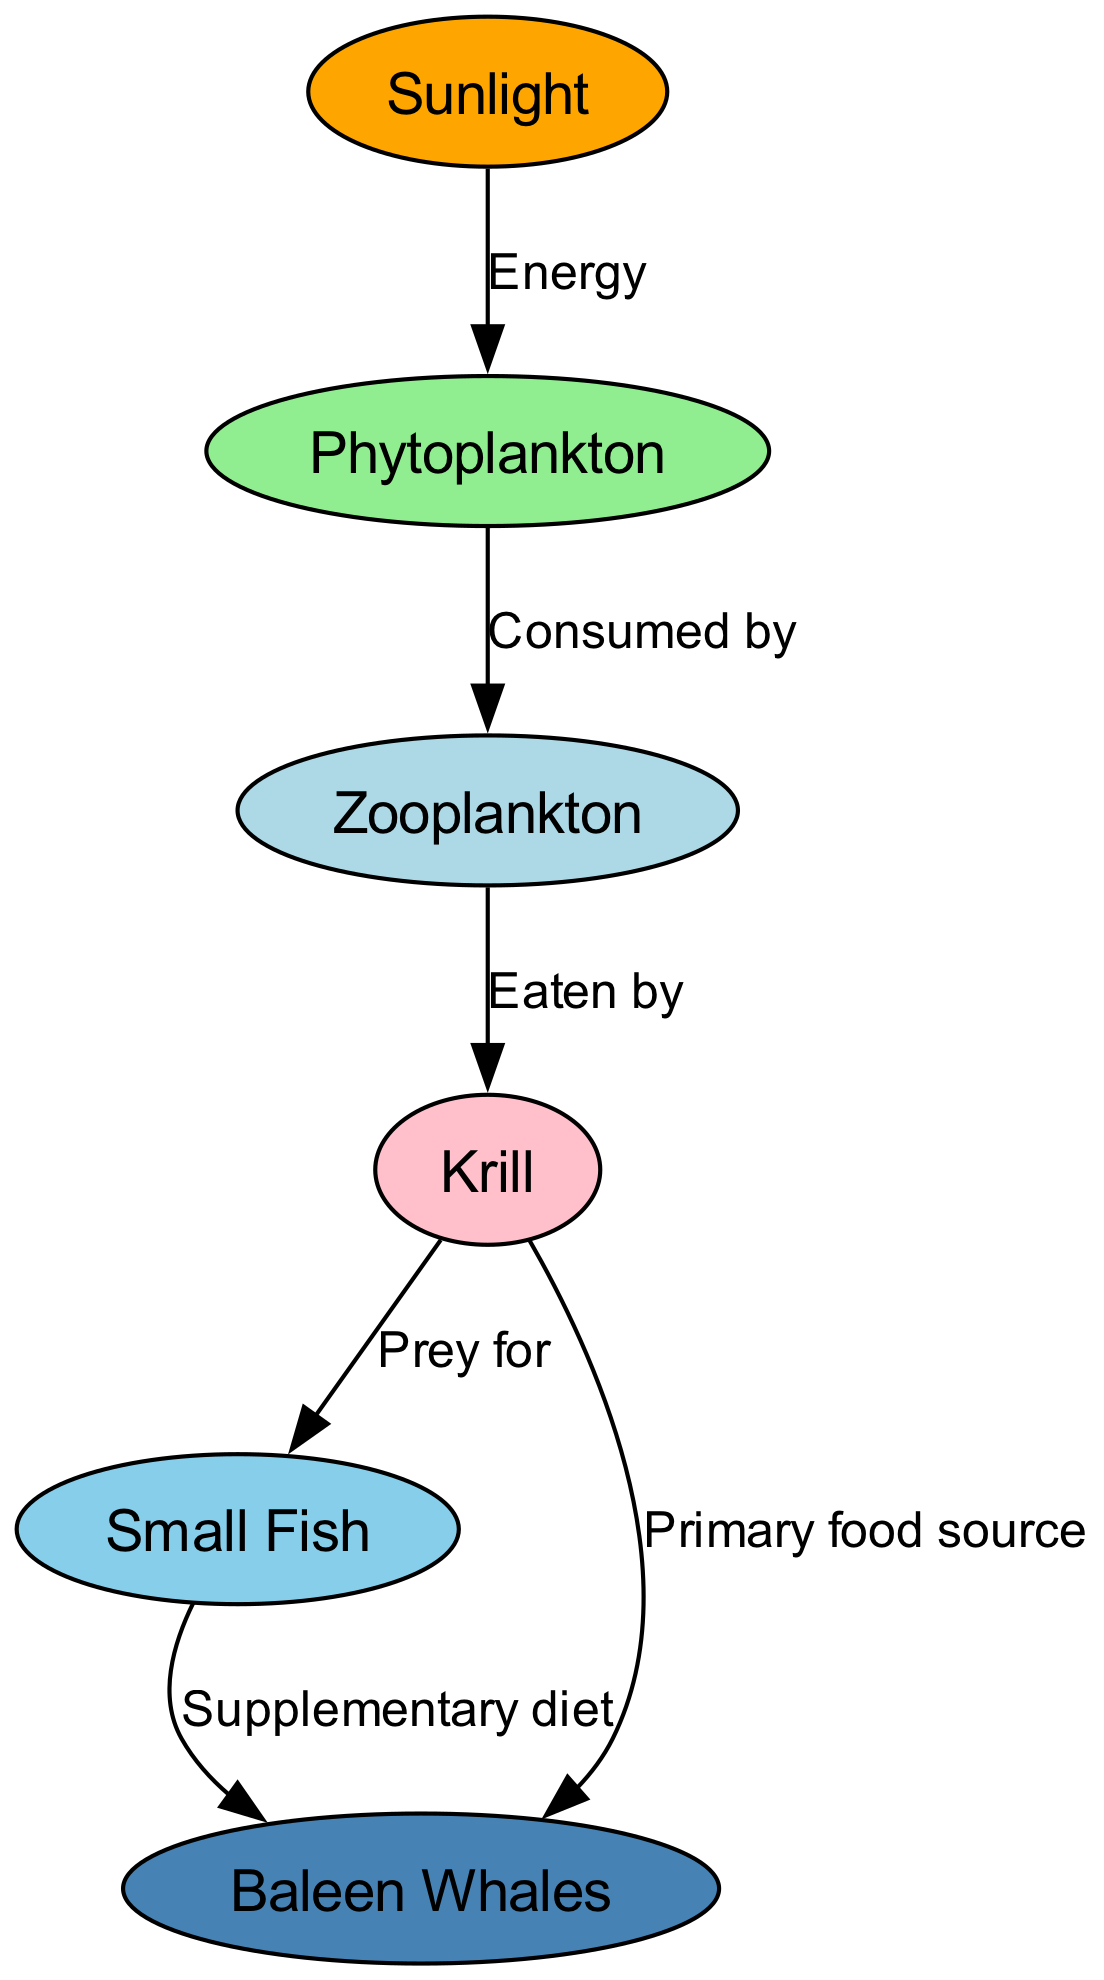What is the primary food source for baleen whales? The diagram indicates that krill is the primary food source for baleen whales, which is indicated by the direct edge labeled "Primary food source" connecting krill to baleen whales.
Answer: Krill How many nodes are in the diagram? Counting all the unique nodes depicted in the diagram, there are six nodes: Sunlight, Phytoplankton, Zooplankton, Krill, Small Fish, and Baleen Whales.
Answer: 6 What relationship does sunlight have with phytoplankton? The diagram shows that sunlight provides energy to phytoplankton, which is labeled by the edge connecting the two, with the label "Energy" indicating that sunlight is essential for phytoplankton's growth.
Answer: Energy Which organism is eaten by zooplankton? According to the diagram, zooplankton consumes phytoplankton; this direct relationship is indicated by the edge labeled "Consumed by" from phytoplankton to zooplankton.
Answer: Phytoplankton What type of fish supplements the diet of baleen whales? The diagram clearly shows that small fish serve as a supplementary diet for baleen whales, indicated by the edge connecting small fish to baleen whales with the label "Supplementary diet."
Answer: Small Fish Which two organisms are both prey for krill? The diagram illustrates that both small fish and baleen whales are described in connection to krill; however, only small fish is prey for krill while baleen whales rely significantly on krill as their primary food source, but baleen whales are not prey for krill. Thus, this can be interpreted such that the edge leading from krill to small fish indicates the prey relationship.
Answer: Small Fish Which organism is at the top of the food chain in this diagram? In the food chain illustrated here, baleen whales are positioned at the top, as they consume both krill and small fish, making them the apex predators in this chain.
Answer: Baleen Whales What role does krill play in the food chain? Krill primarily serves as a crucial link in the food chain, acting as both a primary food source for baleen whales and a prey for small fish. This dual role indicates krill's importance in bridging different trophic levels in the marine ecosystem.
Answer: Primary food source and prey 